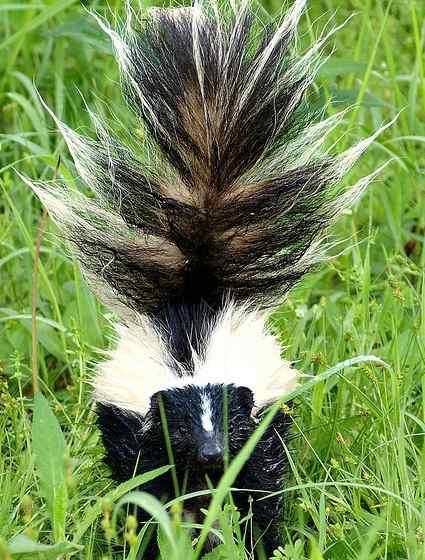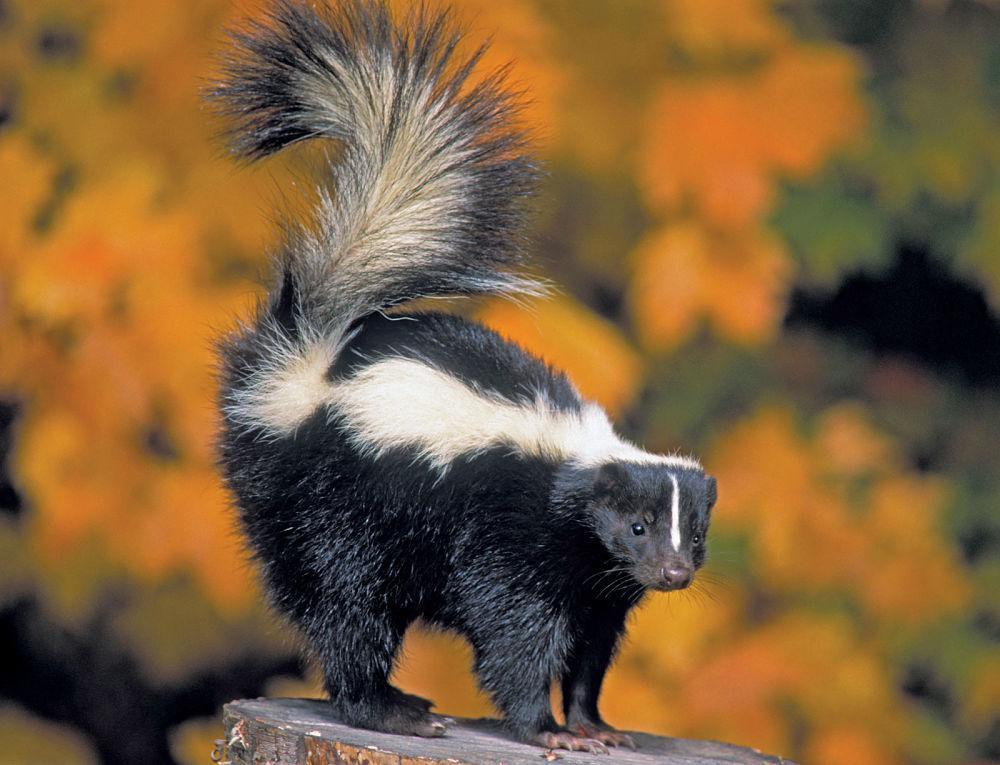The first image is the image on the left, the second image is the image on the right. Evaluate the accuracy of this statement regarding the images: "Each image contains one skunk with its tail raised, and at least one image features a skunk with its body, tail and head facing directly forward.". Is it true? Answer yes or no. Yes. The first image is the image on the left, the second image is the image on the right. For the images shown, is this caption "Both skunks are on the ground." true? Answer yes or no. No. 